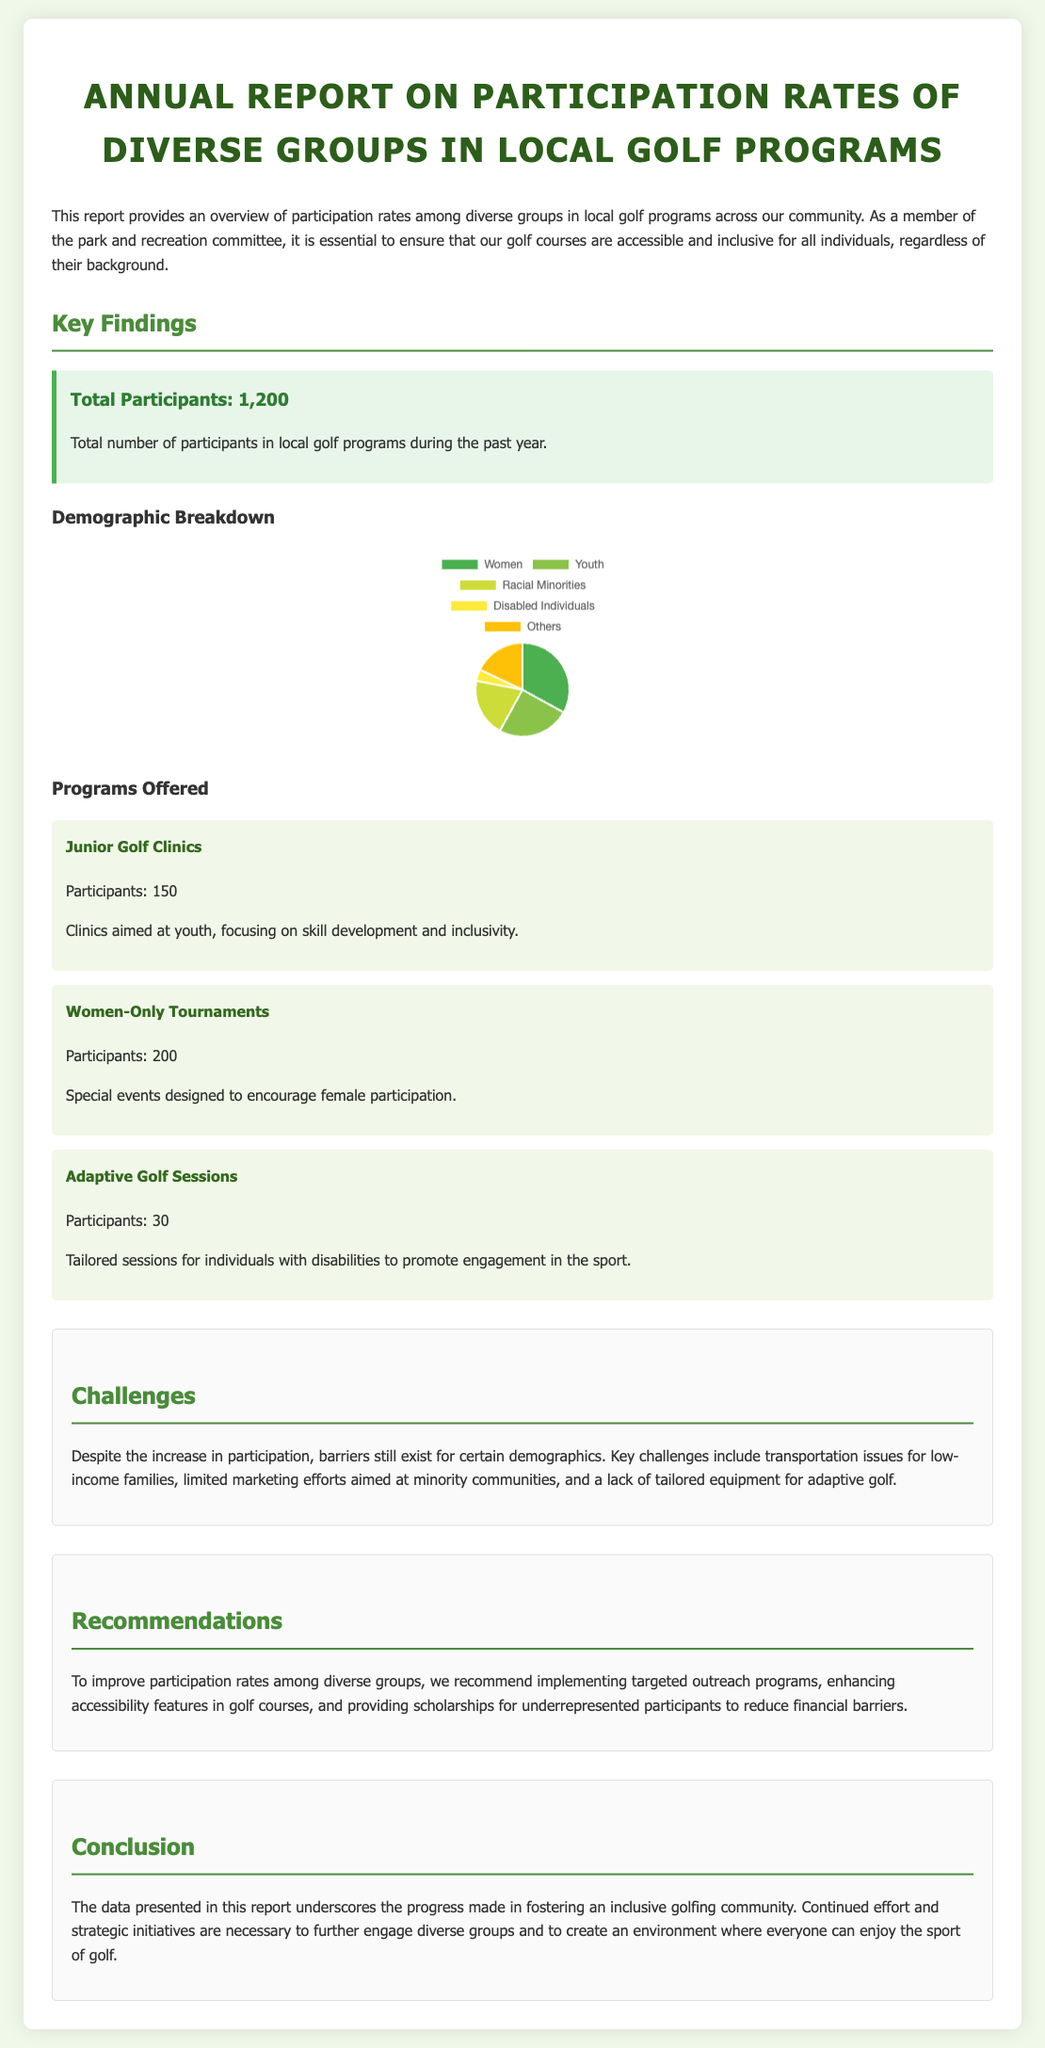what is the total number of participants in local golf programs? The total number of participants mentioned in the document is presented in a key statistic section.
Answer: 1,200 how many participants attend Junior Golf Clinics? The participant count for Junior Golf Clinics is specified in the programs section of the document.
Answer: 150 what percentage of participants are women? The demographic breakdown chart shows the percentage of women among the participants.
Answer: 33 what is one challenge mentioned in the report? A specific challenge faced by diverse groups is provided in the challenges section.
Answer: Transportation issues what recommendation is made to improve participation? Recommendations for improving participation rates are discussed in the recommendations section.
Answer: Targeted outreach programs how many participants are in Adaptive Golf Sessions? The participant number for Adaptive Golf Sessions can be found under the programs offered section.
Answer: 30 what is the title of the report? The title of the document is presented prominently at the top of the report.
Answer: Annual Report on Participation Rates of Diverse Groups in Local Golf Programs what percentage of participants are disabled individuals? The demographic chart includes the percentage of participants that are disabled individuals.
Answer: 4 which program targets women specifically? The program focusing on female participation is listed in the programs offered section.
Answer: Women-Only Tournaments 